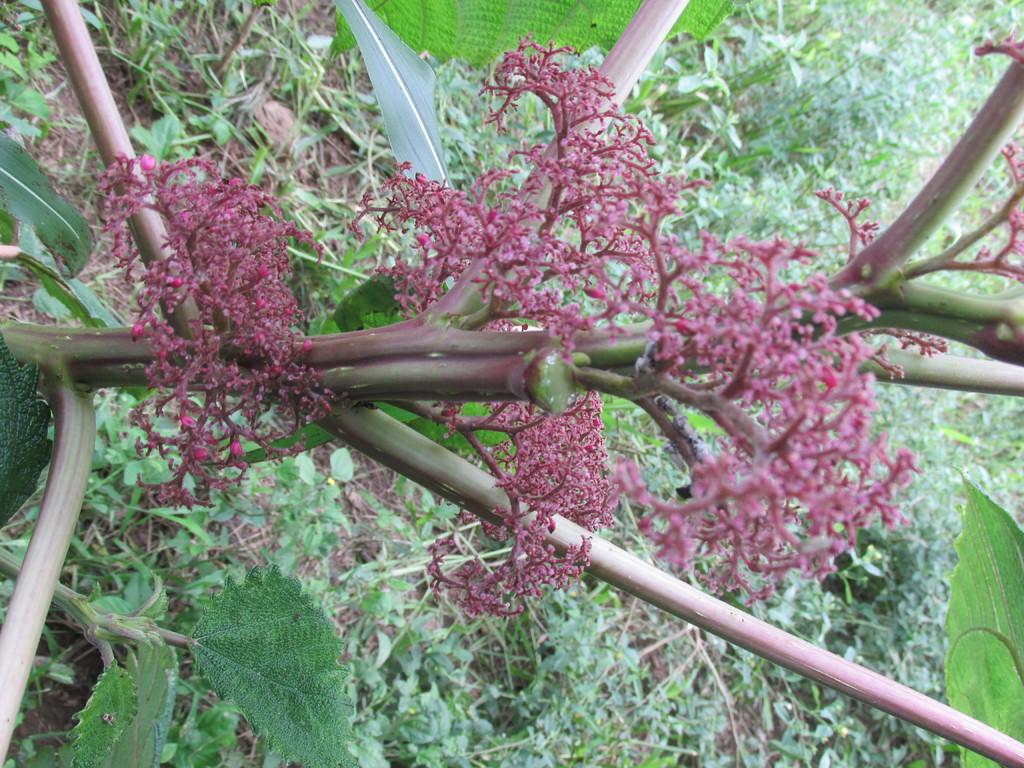What type of living organism can be seen in the image? There is a plant in the image. What type of vegetation is on the ground in the image? Grass is present on the ground in the image. What color is the girl's shirt in the image? There is no girl or shirt present in the image. 